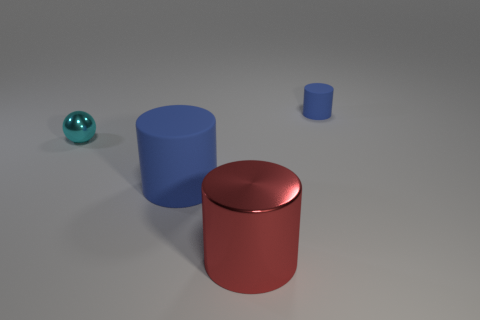Are any purple matte things visible?
Ensure brevity in your answer.  No. Is the shape of the thing behind the tiny cyan shiny sphere the same as the metal object that is to the right of the small cyan ball?
Give a very brief answer. Yes. Is there another cyan sphere made of the same material as the cyan ball?
Your answer should be compact. No. Do the blue cylinder that is to the left of the red cylinder and the red cylinder have the same material?
Offer a very short reply. No. Is the number of tiny blue rubber objects that are to the left of the large red cylinder greater than the number of blue rubber things that are in front of the small metal sphere?
Provide a succinct answer. No. The cylinder that is the same size as the cyan metallic ball is what color?
Make the answer very short. Blue. Is there a metal sphere that has the same color as the small rubber object?
Your answer should be very brief. No. There is a matte thing that is on the right side of the red shiny thing; is it the same color as the rubber cylinder that is in front of the ball?
Ensure brevity in your answer.  Yes. What is the small cyan object that is behind the big red metal cylinder made of?
Offer a terse response. Metal. What color is the other thing that is the same material as the tiny blue object?
Offer a very short reply. Blue. 